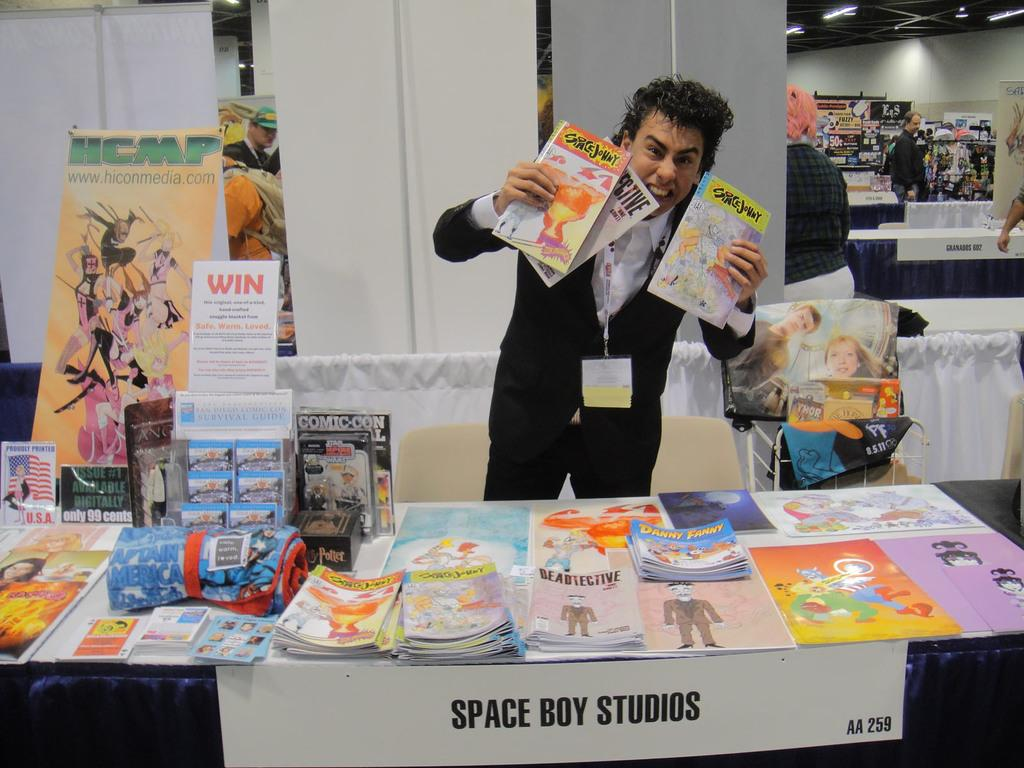<image>
Provide a brief description of the given image. Man holding multiple Space Johny books at a fair. 